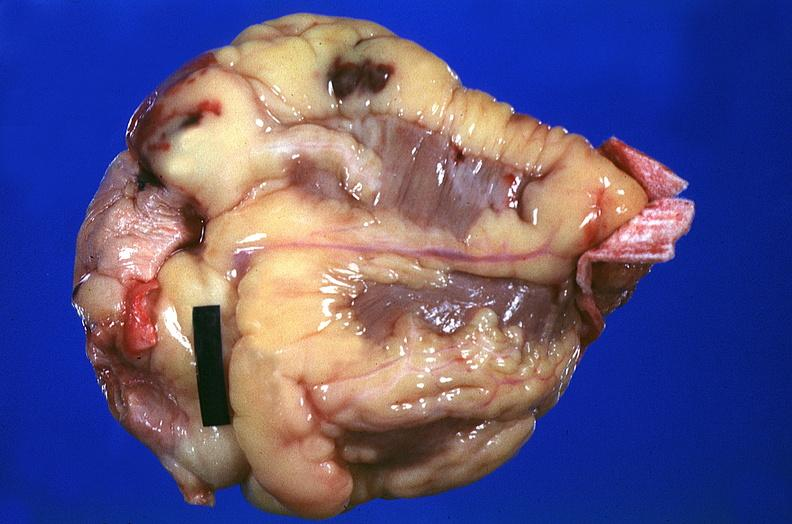what does this image show?
Answer the question using a single word or phrase. Heart 